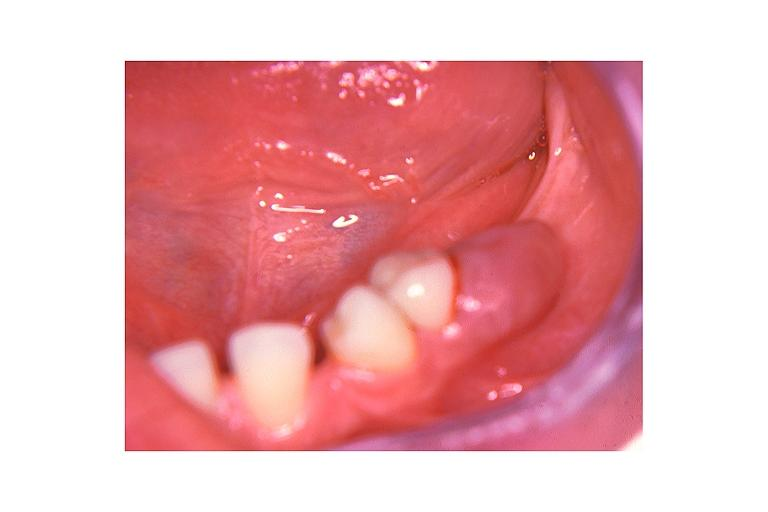what is present?
Answer the question using a single word or phrase. Oral 